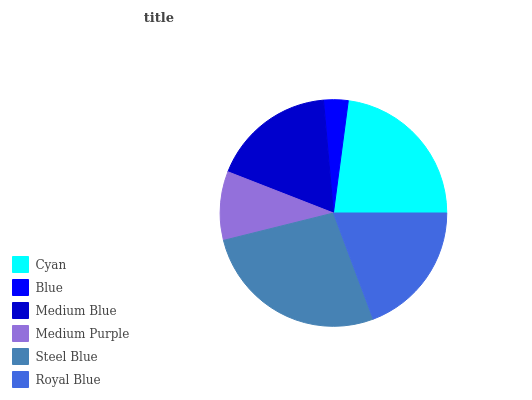Is Blue the minimum?
Answer yes or no. Yes. Is Steel Blue the maximum?
Answer yes or no. Yes. Is Medium Blue the minimum?
Answer yes or no. No. Is Medium Blue the maximum?
Answer yes or no. No. Is Medium Blue greater than Blue?
Answer yes or no. Yes. Is Blue less than Medium Blue?
Answer yes or no. Yes. Is Blue greater than Medium Blue?
Answer yes or no. No. Is Medium Blue less than Blue?
Answer yes or no. No. Is Royal Blue the high median?
Answer yes or no. Yes. Is Medium Blue the low median?
Answer yes or no. Yes. Is Medium Blue the high median?
Answer yes or no. No. Is Cyan the low median?
Answer yes or no. No. 